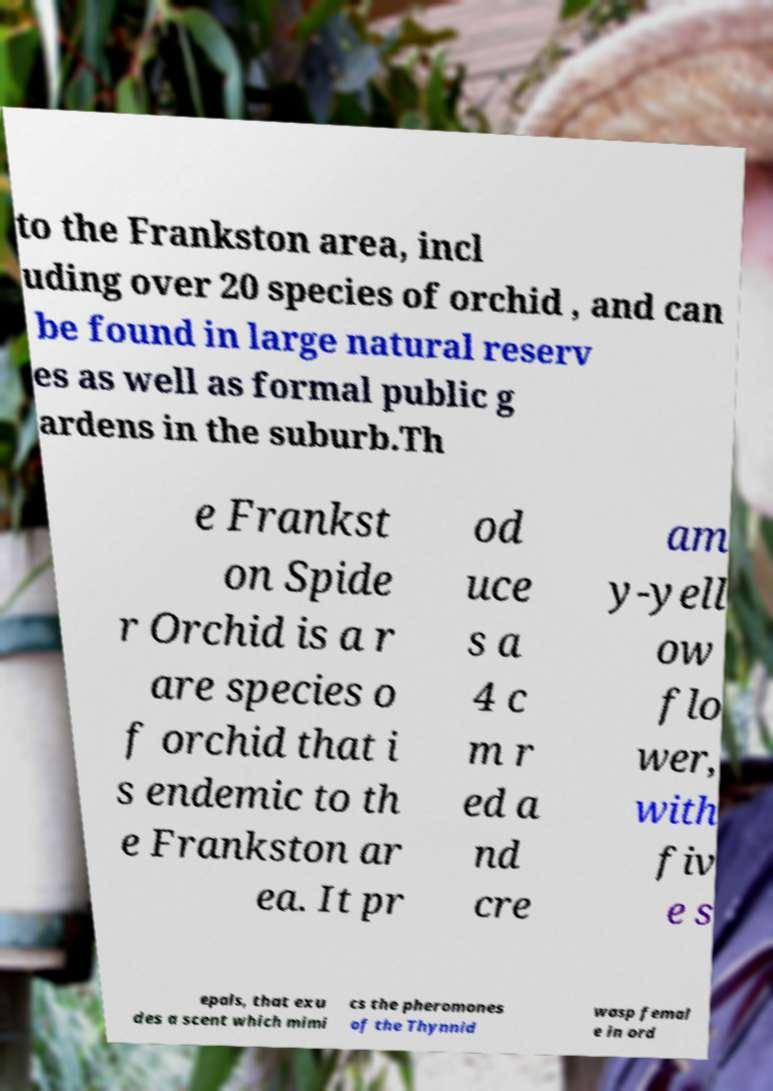Could you extract and type out the text from this image? to the Frankston area, incl uding over 20 species of orchid , and can be found in large natural reserv es as well as formal public g ardens in the suburb.Th e Frankst on Spide r Orchid is a r are species o f orchid that i s endemic to th e Frankston ar ea. It pr od uce s a 4 c m r ed a nd cre am y-yell ow flo wer, with fiv e s epals, that exu des a scent which mimi cs the pheromones of the Thynnid wasp femal e in ord 